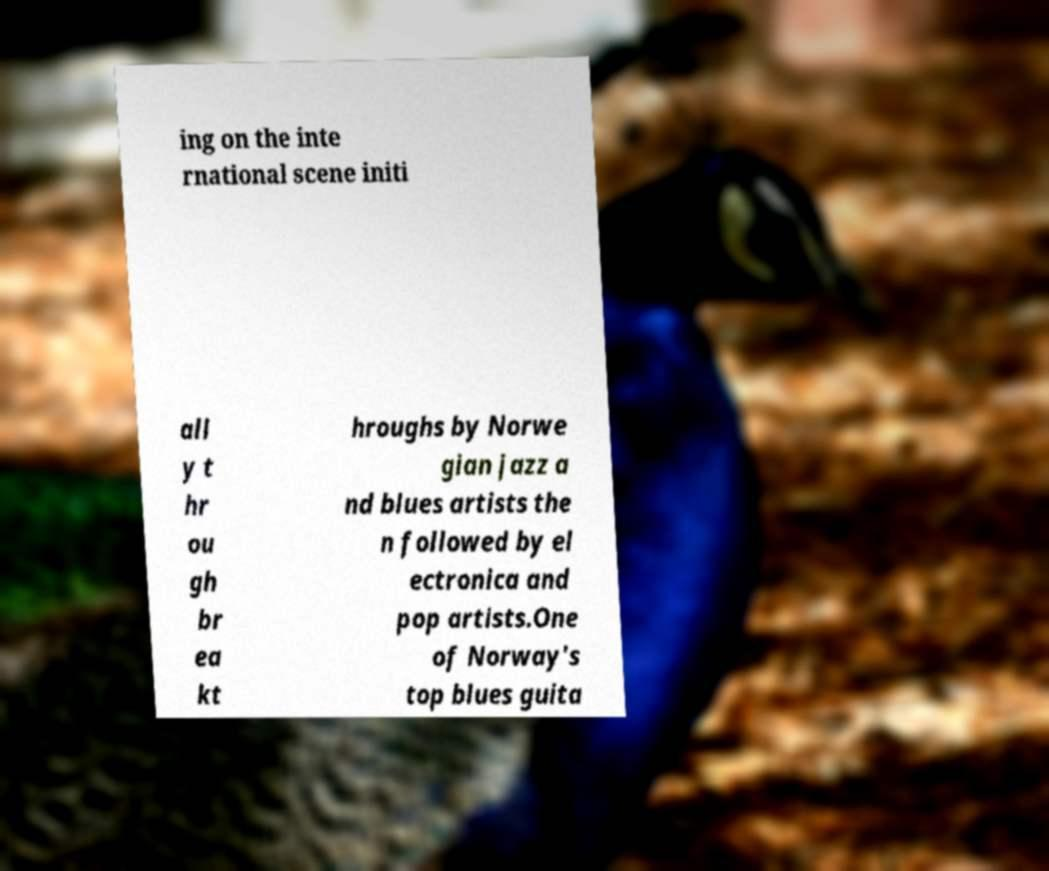I need the written content from this picture converted into text. Can you do that? ing on the inte rnational scene initi all y t hr ou gh br ea kt hroughs by Norwe gian jazz a nd blues artists the n followed by el ectronica and pop artists.One of Norway's top blues guita 